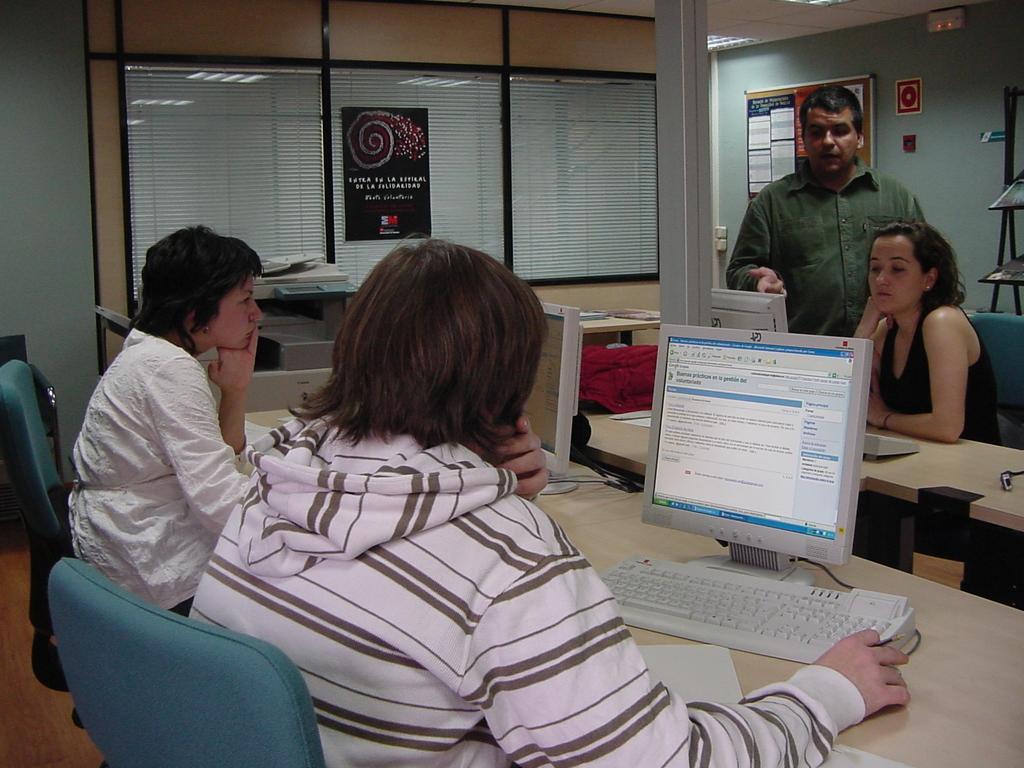Describe this image in one or two sentences. In this image I can see the computers on the table. I can see some people. I can see the chairs. I can see some objects on the table. In the background, I can see a board with some text written on it. I can see the window blinds. At the top I can see the lights. 